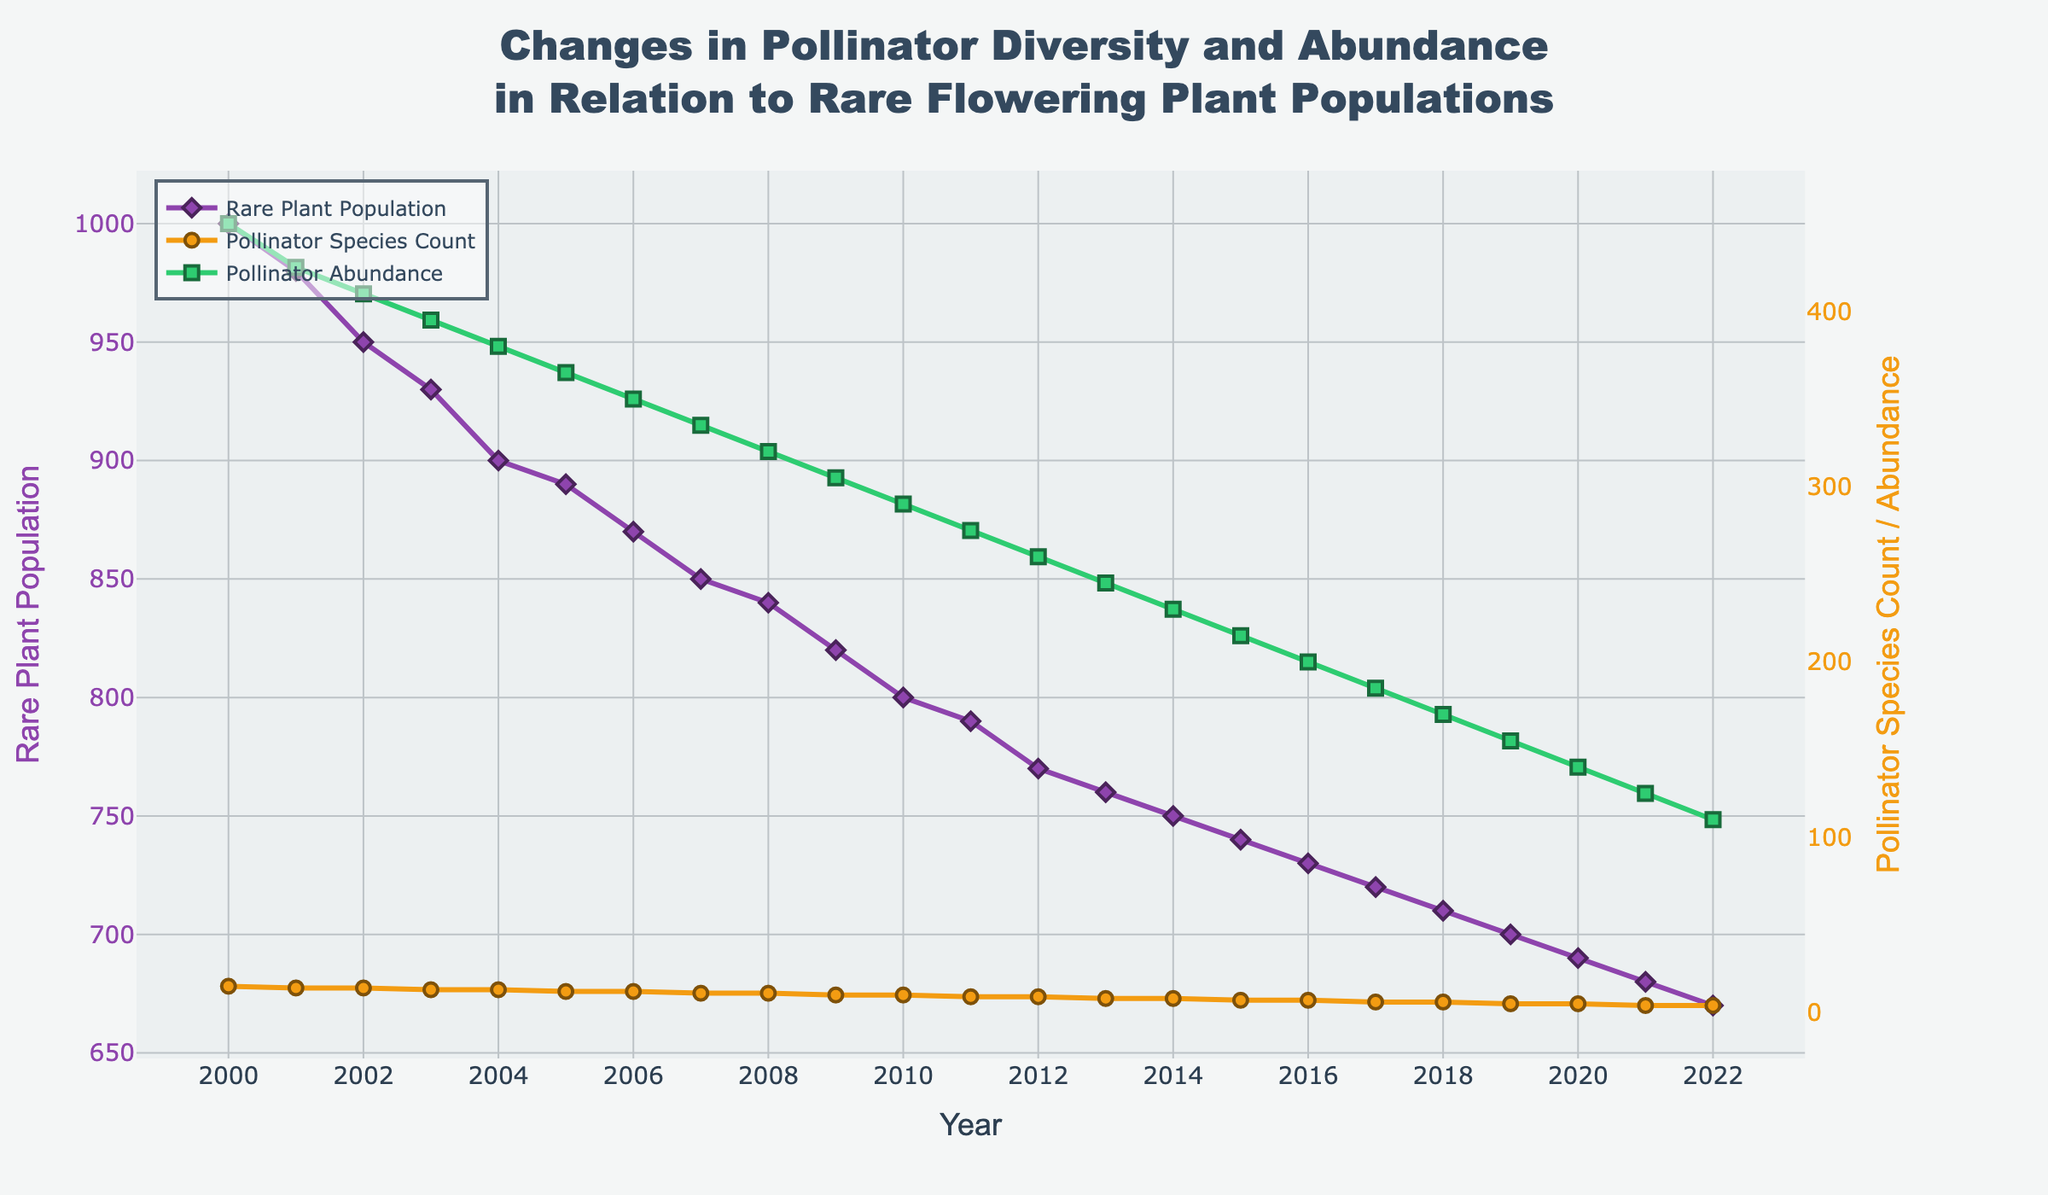What is the trend in the rare plant population from 2000 to 2022? The rare plant population shows a declining trend from 1000 in 2000 to 670 in 2022.
Answer: Declining How does the pollinator species count change in relation to the rare plant population over time? As the rare plant population decreases, the pollinator species count also shows a declining trend, starting from 15 species in 2000 to 4 species in 2022.
Answer: Declining Which year experienced the highest pollinator abundance? The highest pollinator abundance is observed in 2000 with an abundance of 450.
Answer: 2000 Compare the rates of decline for the rare plant population and pollinator abundance from 2000 to 2022. Are they proportional? The rare plant population declines from 1000 to 670, a reduction of 33%, while pollinator abundance falls from 450 to 110, a reduction of approximately 76%. The rates of decline are not proportional; pollinator abundance declines at a faster rate.
Answer: Not proportional What is the average pollinator species count over the entire period? The pollinator species count over 23 years, from 2000 to 2022, averages out to 9 species. This is calculated by summing individual yearly counts and dividing by the number of years: (15+14+14+13+...+4) / 23.
Answer: 9 species In which year does the rare plant population reach the lowest count, and what is the corresponding pollinator abundance in that year? The rare plant population reaches its lowest count in 2022 with a population of 670. The corresponding pollinator abundance is 110.
Answer: 2022, 110 What visual cues help differentiate the trends of rare plant population, pollinator species count, and pollinator abundance? The rare plant population is represented by a line with diamond markers in purple, the pollinator species count by a line with circle markers in orange, and the pollinator abundance by a line with square markers in green, which helps in distinguishing their trends.
Answer: Color and marker type differences Is there a year where the pollinator species count remains the same while the rare plant population changes? Yes, from 2001 to 2002 and from 2006 to 2007, the pollinator species count remains the same (14 and 12 respectively) while the rare plant population decreases in both cases.
Answer: 2001-2002, 2006-2007 How does the title enhance the understanding of the figure? The title clearly indicates that the figure shows changes in pollinator diversity and abundance in relation to rare flowering plant populations over time, providing context and focus for interpreting the data trends.
Answer: Provides context and focus 